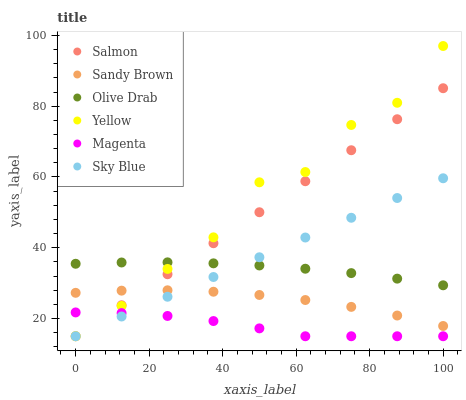Does Magenta have the minimum area under the curve?
Answer yes or no. Yes. Does Yellow have the maximum area under the curve?
Answer yes or no. Yes. Does Sky Blue have the minimum area under the curve?
Answer yes or no. No. Does Sky Blue have the maximum area under the curve?
Answer yes or no. No. Is Sky Blue the smoothest?
Answer yes or no. Yes. Is Yellow the roughest?
Answer yes or no. Yes. Is Yellow the smoothest?
Answer yes or no. No. Is Sky Blue the roughest?
Answer yes or no. No. Does Salmon have the lowest value?
Answer yes or no. Yes. Does Sandy Brown have the lowest value?
Answer yes or no. No. Does Yellow have the highest value?
Answer yes or no. Yes. Does Sky Blue have the highest value?
Answer yes or no. No. Is Magenta less than Olive Drab?
Answer yes or no. Yes. Is Sandy Brown greater than Magenta?
Answer yes or no. Yes. Does Magenta intersect Yellow?
Answer yes or no. Yes. Is Magenta less than Yellow?
Answer yes or no. No. Is Magenta greater than Yellow?
Answer yes or no. No. Does Magenta intersect Olive Drab?
Answer yes or no. No. 